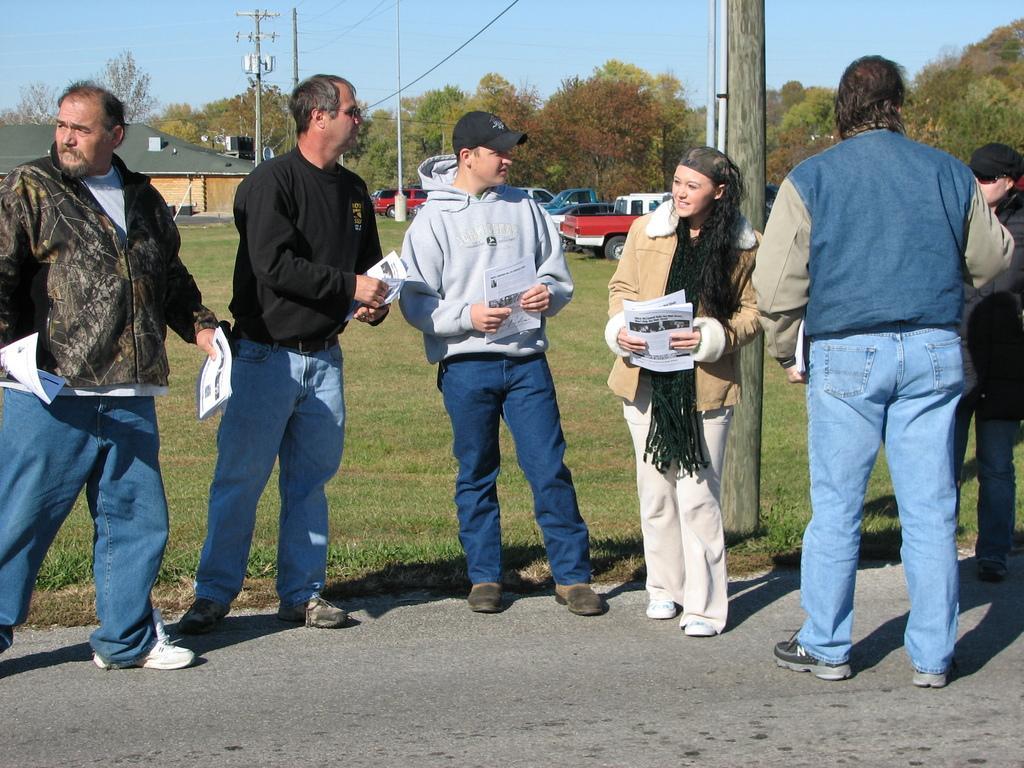Can you describe this image briefly? In this image there is a road. There are people standing on the road. There is grass. There are trees in the background and cars are parked. There is a house on the left side. There is a sky. 